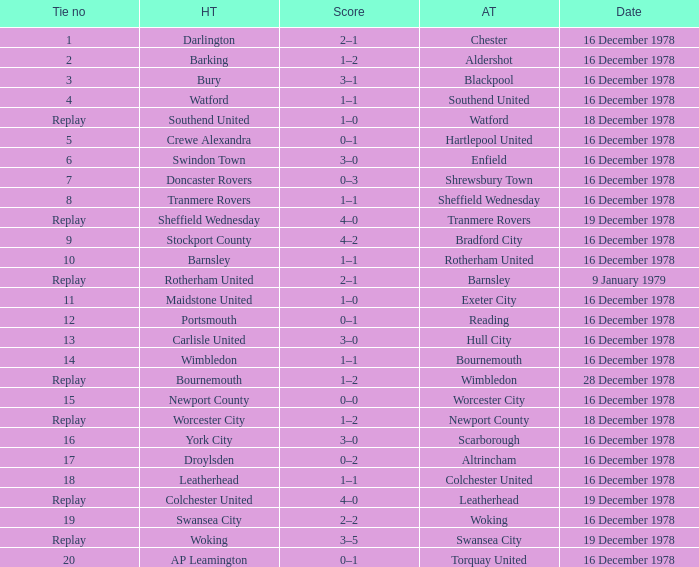What date had a tie no of replay, and an away team of watford? 18 December 1978. 